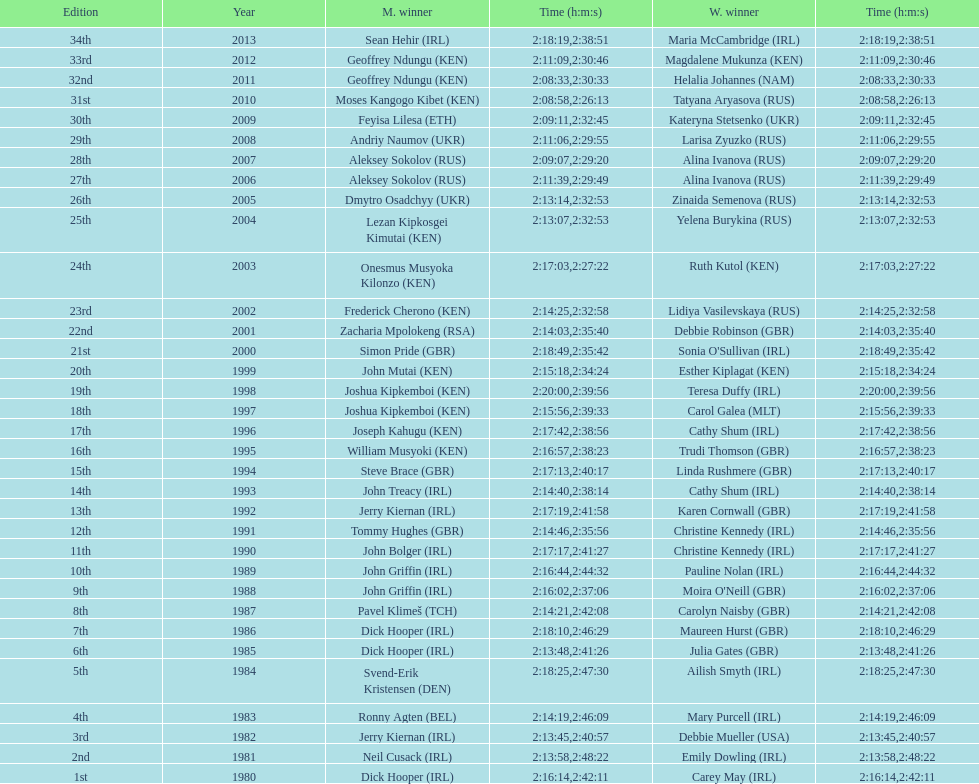Who had the most amount of time out of all the runners? Maria McCambridge (IRL). 